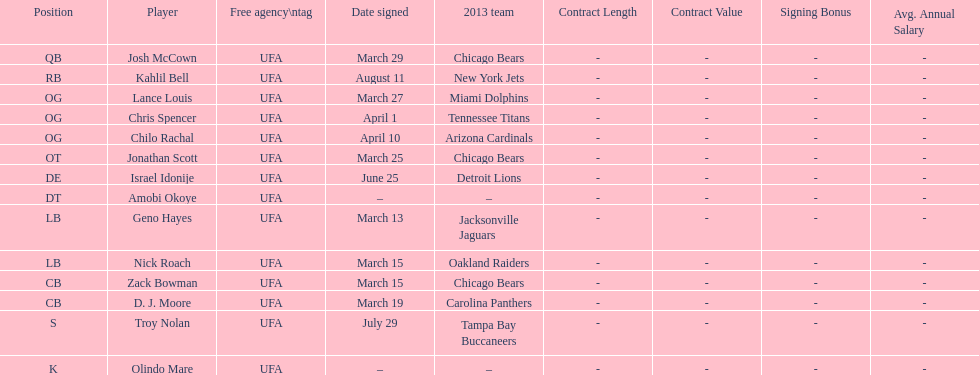What is a surname that can also be used as a first name starting with "n"? Troy Nolan. Parse the table in full. {'header': ['Position', 'Player', 'Free agency\\ntag', 'Date signed', '2013 team', 'Contract Length', 'Contract Value', 'Signing Bonus', 'Avg. Annual Salary'], 'rows': [['QB', 'Josh McCown', 'UFA', 'March 29', 'Chicago Bears', '-', '-', '-', '-'], ['RB', 'Kahlil Bell', 'UFA', 'August 11', 'New York Jets', '-', '-', '-', '-'], ['OG', 'Lance Louis', 'UFA', 'March 27', 'Miami Dolphins', '-', '-', '-', '-'], ['OG', 'Chris Spencer', 'UFA', 'April 1', 'Tennessee Titans', '-', '-', '-', '-'], ['OG', 'Chilo Rachal', 'UFA', 'April 10', 'Arizona Cardinals', '-', '-', '-', '-'], ['OT', 'Jonathan Scott', 'UFA', 'March 25', 'Chicago Bears', '-', '-', '-', '-'], ['DE', 'Israel Idonije', 'UFA', 'June 25', 'Detroit Lions', '-', '-', '-', '-'], ['DT', 'Amobi Okoye', 'UFA', '–', '–', '-', '-', '-', '-'], ['LB', 'Geno Hayes', 'UFA', 'March 13', 'Jacksonville Jaguars', '-', '-', '-', '-'], ['LB', 'Nick Roach', 'UFA', 'March 15', 'Oakland Raiders', '-', '-', '-', '-'], ['CB', 'Zack Bowman', 'UFA', 'March 15', 'Chicago Bears', '-', '-', '-', '-'], ['CB', 'D. J. Moore', 'UFA', 'March 19', 'Carolina Panthers', '-', '-', '-', '-'], ['S', 'Troy Nolan', 'UFA', 'July 29', 'Tampa Bay Buccaneers', '-', '-', '-', '-'], ['K', 'Olindo Mare', 'UFA', '–', '–', '-', '-', '-', '-']]} 